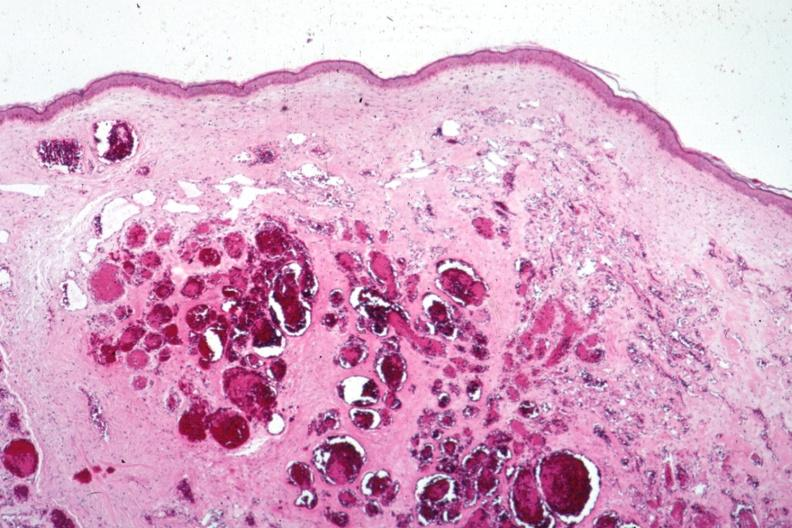what does this image show?
Answer the question using a single word or phrase. Typical cavernous lesion 